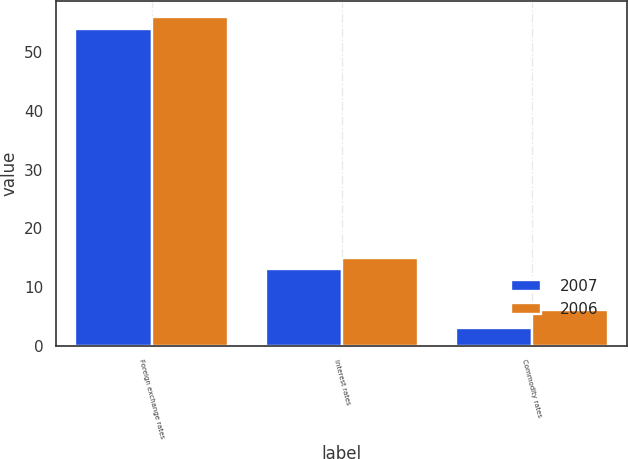Convert chart. <chart><loc_0><loc_0><loc_500><loc_500><stacked_bar_chart><ecel><fcel>Foreign exchange rates<fcel>Interest rates<fcel>Commodity rates<nl><fcel>2007<fcel>54<fcel>13<fcel>3<nl><fcel>2006<fcel>56<fcel>15<fcel>6<nl></chart> 